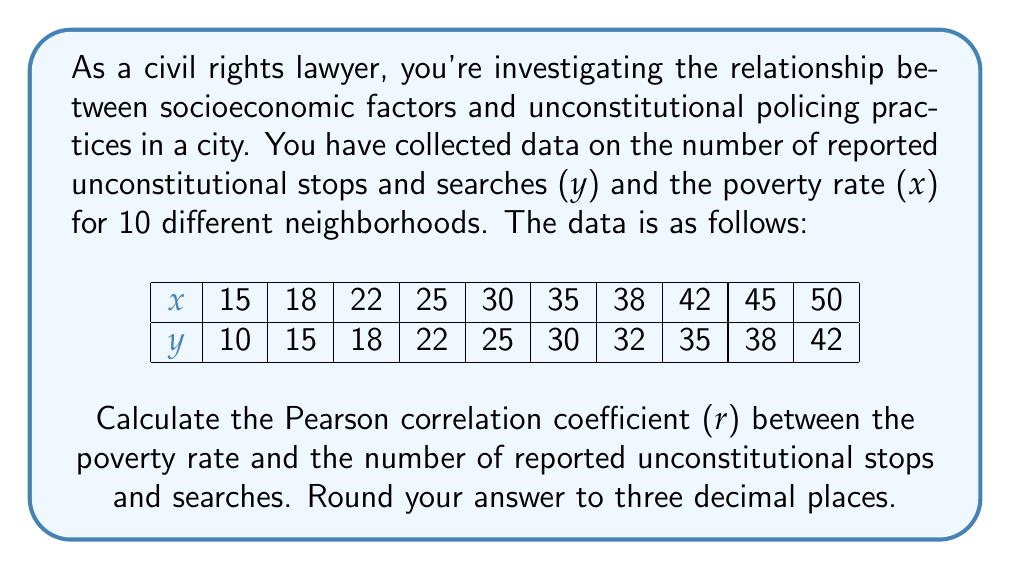What is the answer to this math problem? To calculate the Pearson correlation coefficient (r), we'll use the formula:

$$ r = \frac{n\sum xy - \sum x \sum y}{\sqrt{[n\sum x^2 - (\sum x)^2][n\sum y^2 - (\sum y)^2]}} $$

Where:
n = number of pairs of data
x = poverty rate
y = number of reported unconstitutional stops and searches

Step 1: Calculate the required sums:
$\sum x = 320$
$\sum y = 267$
$\sum xy = 9,305$
$\sum x^2 = 11,678$
$\sum y^2 = 7,915$
n = 10

Step 2: Substitute these values into the formula:

$$ r = \frac{10(9,305) - (320)(267)}{\sqrt{[10(11,678) - 320^2][10(7,915) - 267^2]}} $$

Step 3: Simplify:

$$ r = \frac{93,050 - 85,440}{\sqrt{(116,780 - 102,400)(79,150 - 71,289)}} $$

$$ r = \frac{7,610}{\sqrt{(14,380)(7,861)}} $$

$$ r = \frac{7,610}{\sqrt{113,041,180}} $$

$$ r = \frac{7,610}{10,632.08} $$

$$ r \approx 0.7158 $$

Step 4: Round to three decimal places:

$$ r \approx 0.716 $$

This strong positive correlation suggests that as the poverty rate increases in a neighborhood, the number of reported unconstitutional stops and searches tends to increase as well.
Answer: 0.716 